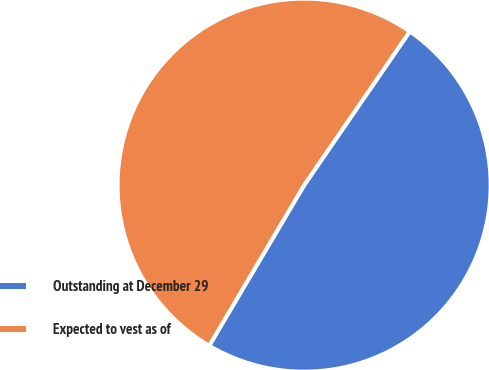Convert chart. <chart><loc_0><loc_0><loc_500><loc_500><pie_chart><fcel>Outstanding at December 29<fcel>Expected to vest as of<nl><fcel>48.92%<fcel>51.08%<nl></chart> 